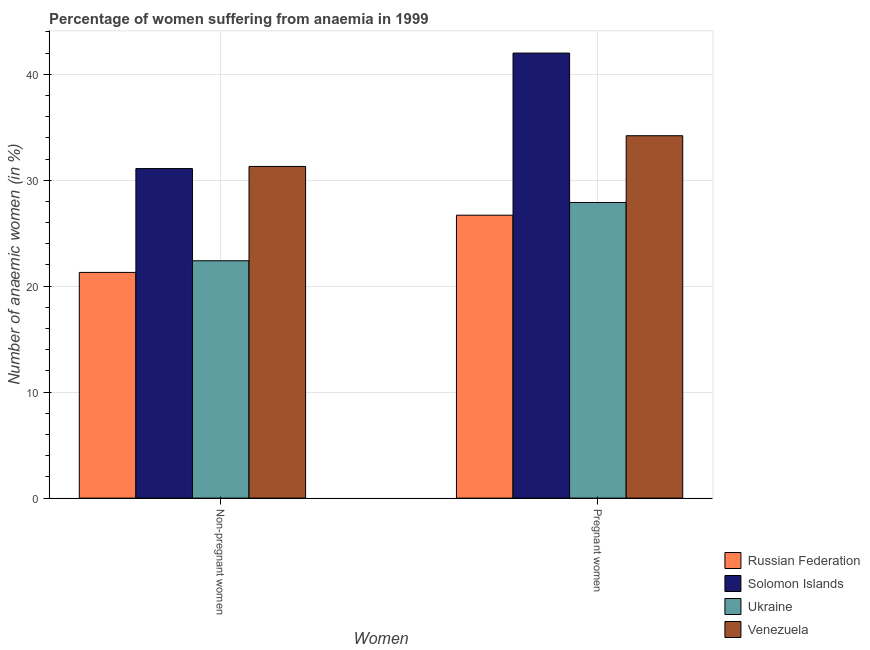How many groups of bars are there?
Ensure brevity in your answer.  2. How many bars are there on the 2nd tick from the right?
Ensure brevity in your answer.  4. What is the label of the 2nd group of bars from the left?
Give a very brief answer. Pregnant women. What is the percentage of non-pregnant anaemic women in Ukraine?
Provide a succinct answer. 22.4. Across all countries, what is the maximum percentage of non-pregnant anaemic women?
Make the answer very short. 31.3. Across all countries, what is the minimum percentage of non-pregnant anaemic women?
Ensure brevity in your answer.  21.3. In which country was the percentage of pregnant anaemic women maximum?
Give a very brief answer. Solomon Islands. In which country was the percentage of non-pregnant anaemic women minimum?
Your response must be concise. Russian Federation. What is the total percentage of pregnant anaemic women in the graph?
Provide a succinct answer. 130.8. What is the difference between the percentage of pregnant anaemic women in Venezuela and that in Russian Federation?
Your response must be concise. 7.5. What is the difference between the percentage of non-pregnant anaemic women in Russian Federation and the percentage of pregnant anaemic women in Venezuela?
Provide a short and direct response. -12.9. What is the average percentage of non-pregnant anaemic women per country?
Your answer should be compact. 26.53. What is the difference between the percentage of non-pregnant anaemic women and percentage of pregnant anaemic women in Venezuela?
Your response must be concise. -2.9. What is the ratio of the percentage of pregnant anaemic women in Solomon Islands to that in Russian Federation?
Ensure brevity in your answer.  1.57. In how many countries, is the percentage of non-pregnant anaemic women greater than the average percentage of non-pregnant anaemic women taken over all countries?
Your response must be concise. 2. What does the 4th bar from the left in Pregnant women represents?
Make the answer very short. Venezuela. What does the 3rd bar from the right in Pregnant women represents?
Give a very brief answer. Solomon Islands. How many bars are there?
Ensure brevity in your answer.  8. Are all the bars in the graph horizontal?
Offer a very short reply. No. What is the difference between two consecutive major ticks on the Y-axis?
Your response must be concise. 10. Does the graph contain grids?
Keep it short and to the point. Yes. What is the title of the graph?
Provide a short and direct response. Percentage of women suffering from anaemia in 1999. Does "OECD members" appear as one of the legend labels in the graph?
Offer a terse response. No. What is the label or title of the X-axis?
Your answer should be very brief. Women. What is the label or title of the Y-axis?
Your response must be concise. Number of anaemic women (in %). What is the Number of anaemic women (in %) of Russian Federation in Non-pregnant women?
Offer a very short reply. 21.3. What is the Number of anaemic women (in %) in Solomon Islands in Non-pregnant women?
Give a very brief answer. 31.1. What is the Number of anaemic women (in %) of Ukraine in Non-pregnant women?
Your answer should be very brief. 22.4. What is the Number of anaemic women (in %) in Venezuela in Non-pregnant women?
Keep it short and to the point. 31.3. What is the Number of anaemic women (in %) in Russian Federation in Pregnant women?
Keep it short and to the point. 26.7. What is the Number of anaemic women (in %) in Ukraine in Pregnant women?
Offer a terse response. 27.9. What is the Number of anaemic women (in %) in Venezuela in Pregnant women?
Your answer should be compact. 34.2. Across all Women, what is the maximum Number of anaemic women (in %) of Russian Federation?
Keep it short and to the point. 26.7. Across all Women, what is the maximum Number of anaemic women (in %) in Ukraine?
Provide a short and direct response. 27.9. Across all Women, what is the maximum Number of anaemic women (in %) in Venezuela?
Make the answer very short. 34.2. Across all Women, what is the minimum Number of anaemic women (in %) of Russian Federation?
Give a very brief answer. 21.3. Across all Women, what is the minimum Number of anaemic women (in %) of Solomon Islands?
Give a very brief answer. 31.1. Across all Women, what is the minimum Number of anaemic women (in %) in Ukraine?
Ensure brevity in your answer.  22.4. Across all Women, what is the minimum Number of anaemic women (in %) of Venezuela?
Ensure brevity in your answer.  31.3. What is the total Number of anaemic women (in %) of Russian Federation in the graph?
Your answer should be compact. 48. What is the total Number of anaemic women (in %) of Solomon Islands in the graph?
Your answer should be very brief. 73.1. What is the total Number of anaemic women (in %) in Ukraine in the graph?
Your response must be concise. 50.3. What is the total Number of anaemic women (in %) in Venezuela in the graph?
Your answer should be compact. 65.5. What is the difference between the Number of anaemic women (in %) of Russian Federation in Non-pregnant women and that in Pregnant women?
Offer a terse response. -5.4. What is the difference between the Number of anaemic women (in %) of Ukraine in Non-pregnant women and that in Pregnant women?
Provide a short and direct response. -5.5. What is the difference between the Number of anaemic women (in %) in Russian Federation in Non-pregnant women and the Number of anaemic women (in %) in Solomon Islands in Pregnant women?
Your answer should be compact. -20.7. What is the difference between the Number of anaemic women (in %) of Russian Federation in Non-pregnant women and the Number of anaemic women (in %) of Ukraine in Pregnant women?
Make the answer very short. -6.6. What is the difference between the Number of anaemic women (in %) of Russian Federation in Non-pregnant women and the Number of anaemic women (in %) of Venezuela in Pregnant women?
Give a very brief answer. -12.9. What is the difference between the Number of anaemic women (in %) in Solomon Islands in Non-pregnant women and the Number of anaemic women (in %) in Ukraine in Pregnant women?
Ensure brevity in your answer.  3.2. What is the difference between the Number of anaemic women (in %) of Solomon Islands in Non-pregnant women and the Number of anaemic women (in %) of Venezuela in Pregnant women?
Keep it short and to the point. -3.1. What is the difference between the Number of anaemic women (in %) of Ukraine in Non-pregnant women and the Number of anaemic women (in %) of Venezuela in Pregnant women?
Keep it short and to the point. -11.8. What is the average Number of anaemic women (in %) in Russian Federation per Women?
Offer a very short reply. 24. What is the average Number of anaemic women (in %) in Solomon Islands per Women?
Offer a terse response. 36.55. What is the average Number of anaemic women (in %) in Ukraine per Women?
Offer a very short reply. 25.15. What is the average Number of anaemic women (in %) in Venezuela per Women?
Your response must be concise. 32.75. What is the difference between the Number of anaemic women (in %) of Russian Federation and Number of anaemic women (in %) of Ukraine in Non-pregnant women?
Provide a short and direct response. -1.1. What is the difference between the Number of anaemic women (in %) in Solomon Islands and Number of anaemic women (in %) in Ukraine in Non-pregnant women?
Make the answer very short. 8.7. What is the difference between the Number of anaemic women (in %) in Solomon Islands and Number of anaemic women (in %) in Venezuela in Non-pregnant women?
Offer a terse response. -0.2. What is the difference between the Number of anaemic women (in %) of Ukraine and Number of anaemic women (in %) of Venezuela in Non-pregnant women?
Ensure brevity in your answer.  -8.9. What is the difference between the Number of anaemic women (in %) in Russian Federation and Number of anaemic women (in %) in Solomon Islands in Pregnant women?
Provide a succinct answer. -15.3. What is the difference between the Number of anaemic women (in %) of Russian Federation and Number of anaemic women (in %) of Ukraine in Pregnant women?
Make the answer very short. -1.2. What is the difference between the Number of anaemic women (in %) of Russian Federation and Number of anaemic women (in %) of Venezuela in Pregnant women?
Ensure brevity in your answer.  -7.5. What is the ratio of the Number of anaemic women (in %) of Russian Federation in Non-pregnant women to that in Pregnant women?
Your answer should be very brief. 0.8. What is the ratio of the Number of anaemic women (in %) of Solomon Islands in Non-pregnant women to that in Pregnant women?
Give a very brief answer. 0.74. What is the ratio of the Number of anaemic women (in %) in Ukraine in Non-pregnant women to that in Pregnant women?
Ensure brevity in your answer.  0.8. What is the ratio of the Number of anaemic women (in %) in Venezuela in Non-pregnant women to that in Pregnant women?
Provide a succinct answer. 0.92. What is the difference between the highest and the second highest Number of anaemic women (in %) of Russian Federation?
Your answer should be very brief. 5.4. What is the difference between the highest and the second highest Number of anaemic women (in %) of Solomon Islands?
Your response must be concise. 10.9. What is the difference between the highest and the second highest Number of anaemic women (in %) of Ukraine?
Your answer should be compact. 5.5. What is the difference between the highest and the lowest Number of anaemic women (in %) in Russian Federation?
Make the answer very short. 5.4. What is the difference between the highest and the lowest Number of anaemic women (in %) in Ukraine?
Ensure brevity in your answer.  5.5. What is the difference between the highest and the lowest Number of anaemic women (in %) of Venezuela?
Provide a short and direct response. 2.9. 